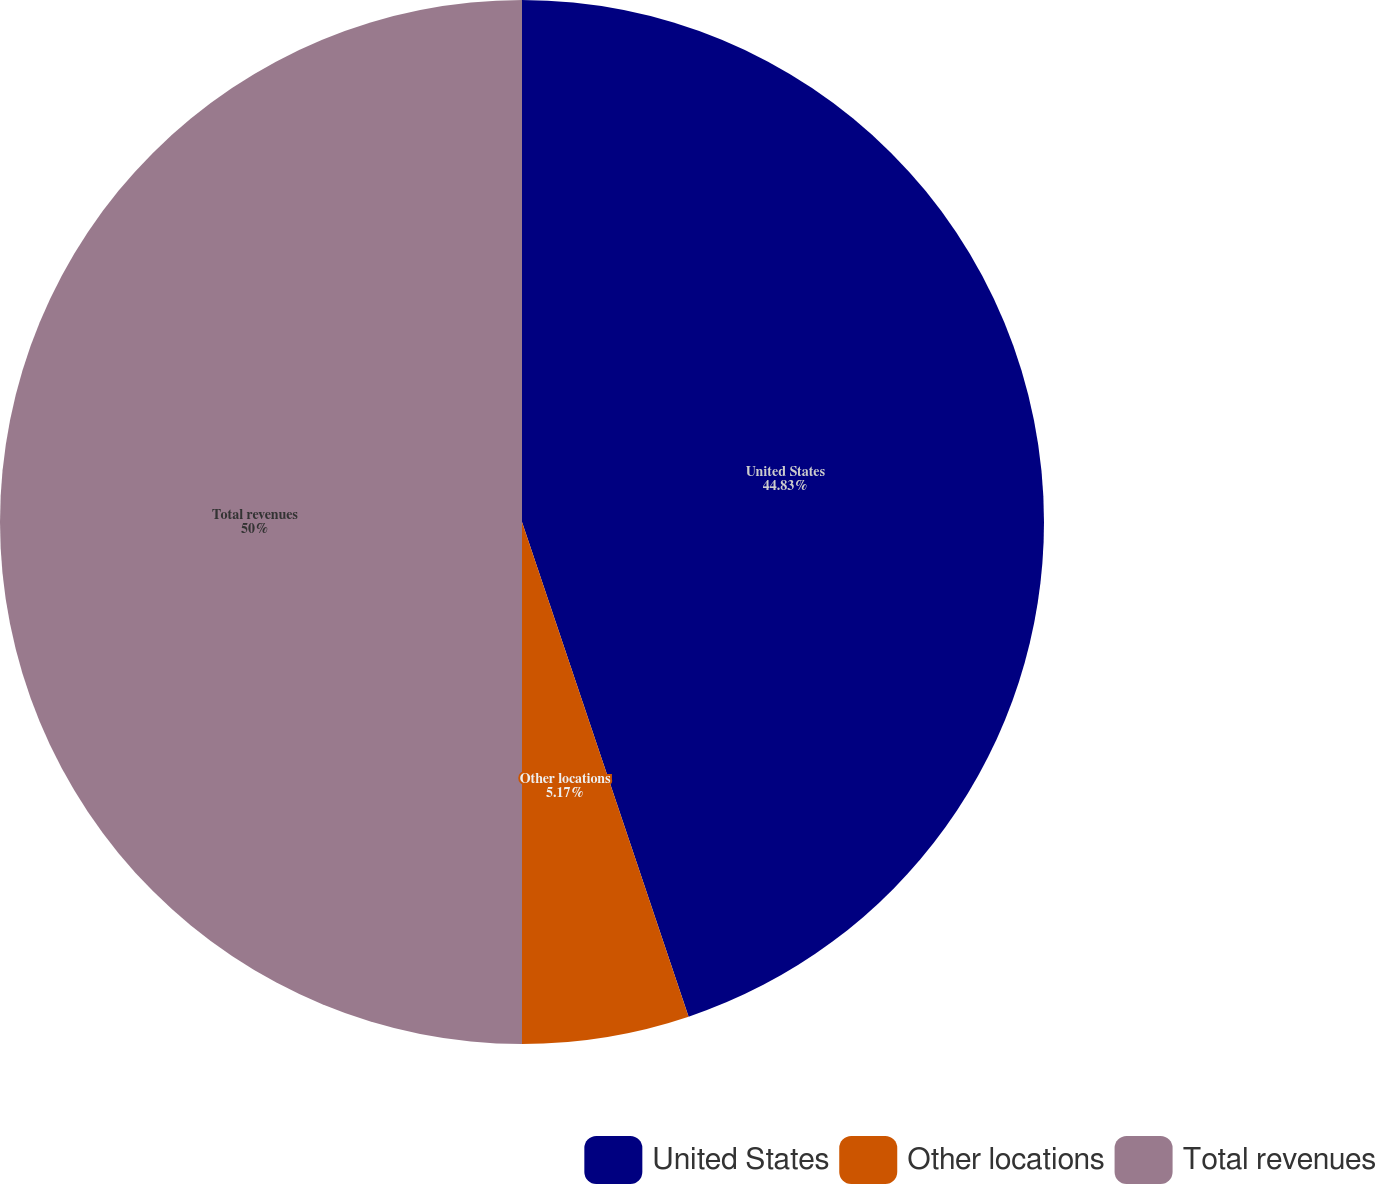<chart> <loc_0><loc_0><loc_500><loc_500><pie_chart><fcel>United States<fcel>Other locations<fcel>Total revenues<nl><fcel>44.83%<fcel>5.17%<fcel>50.0%<nl></chart> 